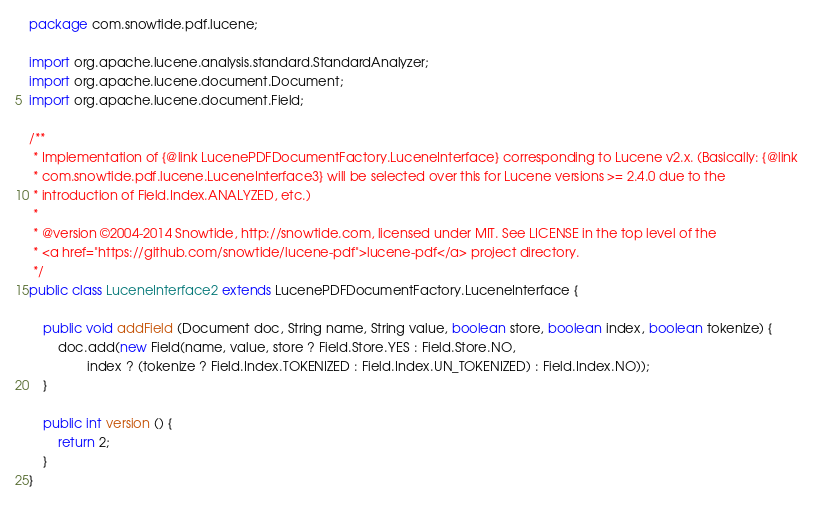<code> <loc_0><loc_0><loc_500><loc_500><_Java_>package com.snowtide.pdf.lucene;

import org.apache.lucene.analysis.standard.StandardAnalyzer;
import org.apache.lucene.document.Document;
import org.apache.lucene.document.Field;

/**
 * Implementation of {@link LucenePDFDocumentFactory.LuceneInterface} corresponding to Lucene v2.x. (Basically: {@link
 * com.snowtide.pdf.lucene.LuceneInterface3} will be selected over this for Lucene versions >= 2.4.0 due to the
 * introduction of Field.Index.ANALYZED, etc.)
 *
 * @version ©2004-2014 Snowtide, http://snowtide.com, licensed under MIT. See LICENSE in the top level of the
 * <a href="https://github.com/snowtide/lucene-pdf">lucene-pdf</a> project directory.
 */
public class LuceneInterface2 extends LucenePDFDocumentFactory.LuceneInterface {

    public void addField (Document doc, String name, String value, boolean store, boolean index, boolean tokenize) {
        doc.add(new Field(name, value, store ? Field.Store.YES : Field.Store.NO,
                index ? (tokenize ? Field.Index.TOKENIZED : Field.Index.UN_TOKENIZED) : Field.Index.NO));
    }

    public int version () {
        return 2;
    }
}
</code> 